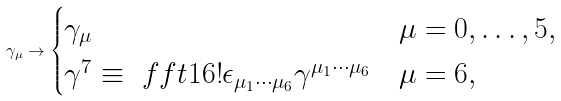Convert formula to latex. <formula><loc_0><loc_0><loc_500><loc_500>\gamma _ { \mu } \to \begin{cases} \gamma _ { \mu } & \mu = 0 , \dots , 5 , \\ \gamma ^ { 7 } \equiv \ f f t 1 { 6 ! } \epsilon _ { \mu _ { 1 } \cdots \mu _ { 6 } } \gamma ^ { \mu _ { 1 } \cdots \mu _ { 6 } } & \mu = 6 , \end{cases}</formula> 